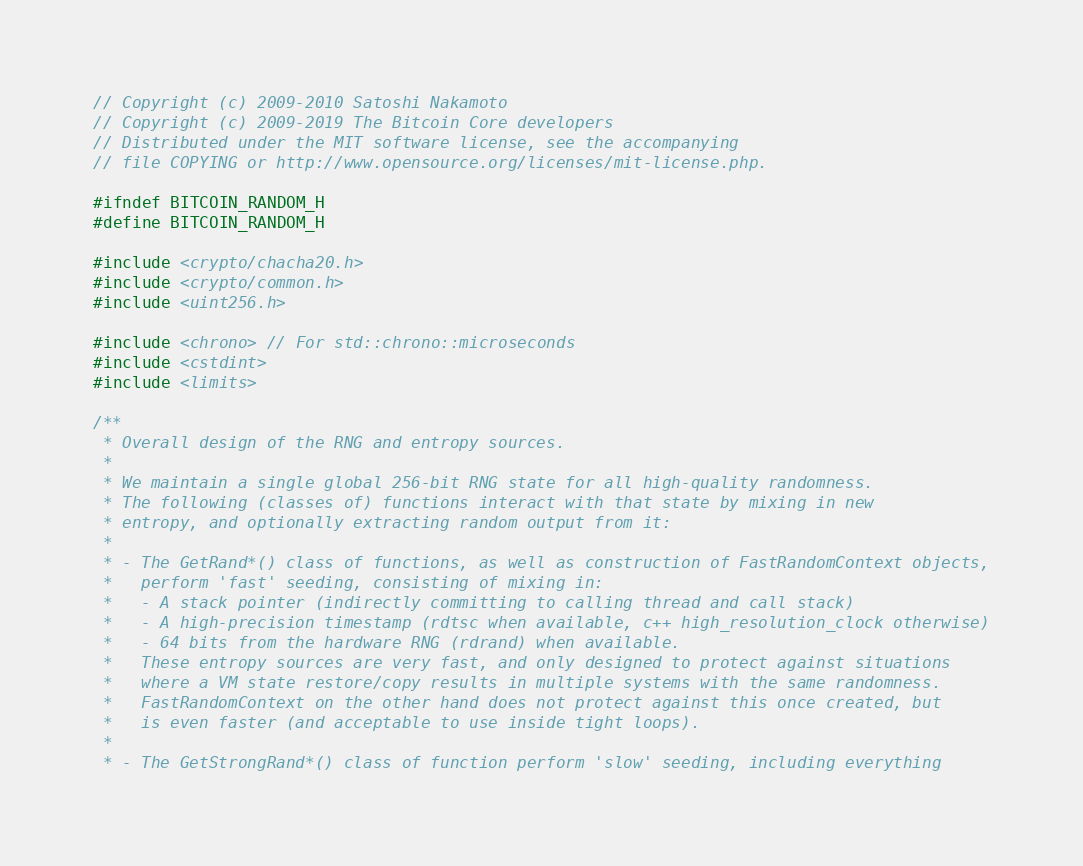Convert code to text. <code><loc_0><loc_0><loc_500><loc_500><_C_>// Copyright (c) 2009-2010 Satoshi Nakamoto
// Copyright (c) 2009-2019 The Bitcoin Core developers
// Distributed under the MIT software license, see the accompanying
// file COPYING or http://www.opensource.org/licenses/mit-license.php.

#ifndef BITCOIN_RANDOM_H
#define BITCOIN_RANDOM_H

#include <crypto/chacha20.h>
#include <crypto/common.h>
#include <uint256.h>

#include <chrono> // For std::chrono::microseconds
#include <cstdint>
#include <limits>

/**
 * Overall design of the RNG and entropy sources.
 *
 * We maintain a single global 256-bit RNG state for all high-quality randomness.
 * The following (classes of) functions interact with that state by mixing in new
 * entropy, and optionally extracting random output from it:
 *
 * - The GetRand*() class of functions, as well as construction of FastRandomContext objects,
 *   perform 'fast' seeding, consisting of mixing in:
 *   - A stack pointer (indirectly committing to calling thread and call stack)
 *   - A high-precision timestamp (rdtsc when available, c++ high_resolution_clock otherwise)
 *   - 64 bits from the hardware RNG (rdrand) when available.
 *   These entropy sources are very fast, and only designed to protect against situations
 *   where a VM state restore/copy results in multiple systems with the same randomness.
 *   FastRandomContext on the other hand does not protect against this once created, but
 *   is even faster (and acceptable to use inside tight loops).
 *
 * - The GetStrongRand*() class of function perform 'slow' seeding, including everything</code> 